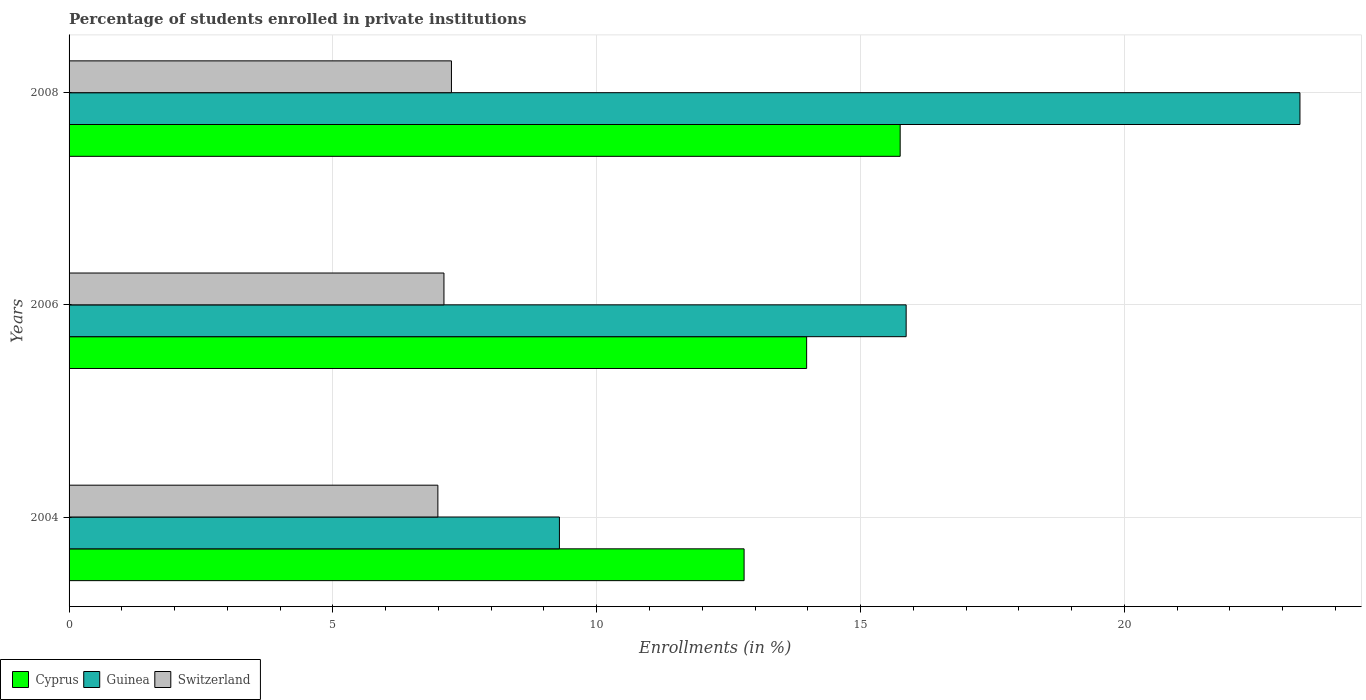Are the number of bars per tick equal to the number of legend labels?
Keep it short and to the point. Yes. How many bars are there on the 2nd tick from the top?
Provide a short and direct response. 3. What is the label of the 3rd group of bars from the top?
Make the answer very short. 2004. In how many cases, is the number of bars for a given year not equal to the number of legend labels?
Your answer should be very brief. 0. What is the percentage of trained teachers in Switzerland in 2006?
Provide a short and direct response. 7.1. Across all years, what is the maximum percentage of trained teachers in Guinea?
Provide a succinct answer. 23.33. Across all years, what is the minimum percentage of trained teachers in Cyprus?
Your answer should be compact. 12.79. In which year was the percentage of trained teachers in Cyprus maximum?
Provide a short and direct response. 2008. In which year was the percentage of trained teachers in Cyprus minimum?
Provide a succinct answer. 2004. What is the total percentage of trained teachers in Guinea in the graph?
Ensure brevity in your answer.  48.49. What is the difference between the percentage of trained teachers in Cyprus in 2006 and that in 2008?
Offer a very short reply. -1.77. What is the difference between the percentage of trained teachers in Switzerland in 2004 and the percentage of trained teachers in Guinea in 2006?
Provide a short and direct response. -8.87. What is the average percentage of trained teachers in Cyprus per year?
Your answer should be compact. 14.17. In the year 2004, what is the difference between the percentage of trained teachers in Guinea and percentage of trained teachers in Switzerland?
Your answer should be very brief. 2.3. What is the ratio of the percentage of trained teachers in Switzerland in 2006 to that in 2008?
Your answer should be very brief. 0.98. What is the difference between the highest and the second highest percentage of trained teachers in Cyprus?
Offer a terse response. 1.77. What is the difference between the highest and the lowest percentage of trained teachers in Cyprus?
Offer a very short reply. 2.96. In how many years, is the percentage of trained teachers in Guinea greater than the average percentage of trained teachers in Guinea taken over all years?
Provide a succinct answer. 1. What does the 2nd bar from the top in 2008 represents?
Keep it short and to the point. Guinea. What does the 2nd bar from the bottom in 2004 represents?
Provide a succinct answer. Guinea. Is it the case that in every year, the sum of the percentage of trained teachers in Guinea and percentage of trained teachers in Switzerland is greater than the percentage of trained teachers in Cyprus?
Ensure brevity in your answer.  Yes. Does the graph contain any zero values?
Provide a succinct answer. No. Does the graph contain grids?
Offer a terse response. Yes. How many legend labels are there?
Ensure brevity in your answer.  3. How are the legend labels stacked?
Your answer should be compact. Horizontal. What is the title of the graph?
Provide a short and direct response. Percentage of students enrolled in private institutions. What is the label or title of the X-axis?
Your answer should be very brief. Enrollments (in %). What is the Enrollments (in %) in Cyprus in 2004?
Provide a short and direct response. 12.79. What is the Enrollments (in %) of Guinea in 2004?
Keep it short and to the point. 9.29. What is the Enrollments (in %) in Switzerland in 2004?
Offer a very short reply. 6.99. What is the Enrollments (in %) of Cyprus in 2006?
Offer a terse response. 13.98. What is the Enrollments (in %) in Guinea in 2006?
Your answer should be very brief. 15.86. What is the Enrollments (in %) in Switzerland in 2006?
Provide a short and direct response. 7.1. What is the Enrollments (in %) in Cyprus in 2008?
Make the answer very short. 15.75. What is the Enrollments (in %) in Guinea in 2008?
Offer a terse response. 23.33. What is the Enrollments (in %) in Switzerland in 2008?
Offer a terse response. 7.25. Across all years, what is the maximum Enrollments (in %) of Cyprus?
Provide a succinct answer. 15.75. Across all years, what is the maximum Enrollments (in %) in Guinea?
Keep it short and to the point. 23.33. Across all years, what is the maximum Enrollments (in %) of Switzerland?
Keep it short and to the point. 7.25. Across all years, what is the minimum Enrollments (in %) of Cyprus?
Provide a short and direct response. 12.79. Across all years, what is the minimum Enrollments (in %) of Guinea?
Keep it short and to the point. 9.29. Across all years, what is the minimum Enrollments (in %) in Switzerland?
Your answer should be compact. 6.99. What is the total Enrollments (in %) in Cyprus in the graph?
Keep it short and to the point. 42.52. What is the total Enrollments (in %) of Guinea in the graph?
Make the answer very short. 48.49. What is the total Enrollments (in %) in Switzerland in the graph?
Your answer should be very brief. 21.34. What is the difference between the Enrollments (in %) of Cyprus in 2004 and that in 2006?
Your response must be concise. -1.19. What is the difference between the Enrollments (in %) of Guinea in 2004 and that in 2006?
Keep it short and to the point. -6.57. What is the difference between the Enrollments (in %) in Switzerland in 2004 and that in 2006?
Offer a very short reply. -0.12. What is the difference between the Enrollments (in %) in Cyprus in 2004 and that in 2008?
Keep it short and to the point. -2.96. What is the difference between the Enrollments (in %) of Guinea in 2004 and that in 2008?
Offer a very short reply. -14.03. What is the difference between the Enrollments (in %) of Switzerland in 2004 and that in 2008?
Keep it short and to the point. -0.26. What is the difference between the Enrollments (in %) of Cyprus in 2006 and that in 2008?
Provide a short and direct response. -1.77. What is the difference between the Enrollments (in %) in Guinea in 2006 and that in 2008?
Give a very brief answer. -7.46. What is the difference between the Enrollments (in %) of Switzerland in 2006 and that in 2008?
Offer a terse response. -0.14. What is the difference between the Enrollments (in %) of Cyprus in 2004 and the Enrollments (in %) of Guinea in 2006?
Your answer should be compact. -3.07. What is the difference between the Enrollments (in %) of Cyprus in 2004 and the Enrollments (in %) of Switzerland in 2006?
Provide a succinct answer. 5.69. What is the difference between the Enrollments (in %) of Guinea in 2004 and the Enrollments (in %) of Switzerland in 2006?
Your answer should be compact. 2.19. What is the difference between the Enrollments (in %) of Cyprus in 2004 and the Enrollments (in %) of Guinea in 2008?
Provide a short and direct response. -10.53. What is the difference between the Enrollments (in %) in Cyprus in 2004 and the Enrollments (in %) in Switzerland in 2008?
Ensure brevity in your answer.  5.55. What is the difference between the Enrollments (in %) in Guinea in 2004 and the Enrollments (in %) in Switzerland in 2008?
Keep it short and to the point. 2.05. What is the difference between the Enrollments (in %) of Cyprus in 2006 and the Enrollments (in %) of Guinea in 2008?
Give a very brief answer. -9.35. What is the difference between the Enrollments (in %) in Cyprus in 2006 and the Enrollments (in %) in Switzerland in 2008?
Make the answer very short. 6.73. What is the difference between the Enrollments (in %) in Guinea in 2006 and the Enrollments (in %) in Switzerland in 2008?
Keep it short and to the point. 8.62. What is the average Enrollments (in %) of Cyprus per year?
Provide a short and direct response. 14.17. What is the average Enrollments (in %) of Guinea per year?
Provide a short and direct response. 16.16. What is the average Enrollments (in %) in Switzerland per year?
Provide a succinct answer. 7.11. In the year 2004, what is the difference between the Enrollments (in %) in Cyprus and Enrollments (in %) in Guinea?
Offer a terse response. 3.5. In the year 2004, what is the difference between the Enrollments (in %) in Cyprus and Enrollments (in %) in Switzerland?
Provide a short and direct response. 5.8. In the year 2004, what is the difference between the Enrollments (in %) of Guinea and Enrollments (in %) of Switzerland?
Offer a terse response. 2.3. In the year 2006, what is the difference between the Enrollments (in %) in Cyprus and Enrollments (in %) in Guinea?
Offer a terse response. -1.89. In the year 2006, what is the difference between the Enrollments (in %) of Cyprus and Enrollments (in %) of Switzerland?
Offer a very short reply. 6.87. In the year 2006, what is the difference between the Enrollments (in %) in Guinea and Enrollments (in %) in Switzerland?
Your response must be concise. 8.76. In the year 2008, what is the difference between the Enrollments (in %) of Cyprus and Enrollments (in %) of Guinea?
Provide a succinct answer. -7.58. In the year 2008, what is the difference between the Enrollments (in %) of Cyprus and Enrollments (in %) of Switzerland?
Provide a succinct answer. 8.5. In the year 2008, what is the difference between the Enrollments (in %) of Guinea and Enrollments (in %) of Switzerland?
Your response must be concise. 16.08. What is the ratio of the Enrollments (in %) of Cyprus in 2004 to that in 2006?
Your answer should be compact. 0.92. What is the ratio of the Enrollments (in %) in Guinea in 2004 to that in 2006?
Make the answer very short. 0.59. What is the ratio of the Enrollments (in %) in Switzerland in 2004 to that in 2006?
Your response must be concise. 0.98. What is the ratio of the Enrollments (in %) of Cyprus in 2004 to that in 2008?
Provide a short and direct response. 0.81. What is the ratio of the Enrollments (in %) in Guinea in 2004 to that in 2008?
Your response must be concise. 0.4. What is the ratio of the Enrollments (in %) in Switzerland in 2004 to that in 2008?
Give a very brief answer. 0.96. What is the ratio of the Enrollments (in %) of Cyprus in 2006 to that in 2008?
Give a very brief answer. 0.89. What is the ratio of the Enrollments (in %) of Guinea in 2006 to that in 2008?
Your answer should be compact. 0.68. What is the ratio of the Enrollments (in %) in Switzerland in 2006 to that in 2008?
Give a very brief answer. 0.98. What is the difference between the highest and the second highest Enrollments (in %) in Cyprus?
Make the answer very short. 1.77. What is the difference between the highest and the second highest Enrollments (in %) of Guinea?
Ensure brevity in your answer.  7.46. What is the difference between the highest and the second highest Enrollments (in %) in Switzerland?
Make the answer very short. 0.14. What is the difference between the highest and the lowest Enrollments (in %) in Cyprus?
Ensure brevity in your answer.  2.96. What is the difference between the highest and the lowest Enrollments (in %) in Guinea?
Provide a succinct answer. 14.03. What is the difference between the highest and the lowest Enrollments (in %) in Switzerland?
Ensure brevity in your answer.  0.26. 